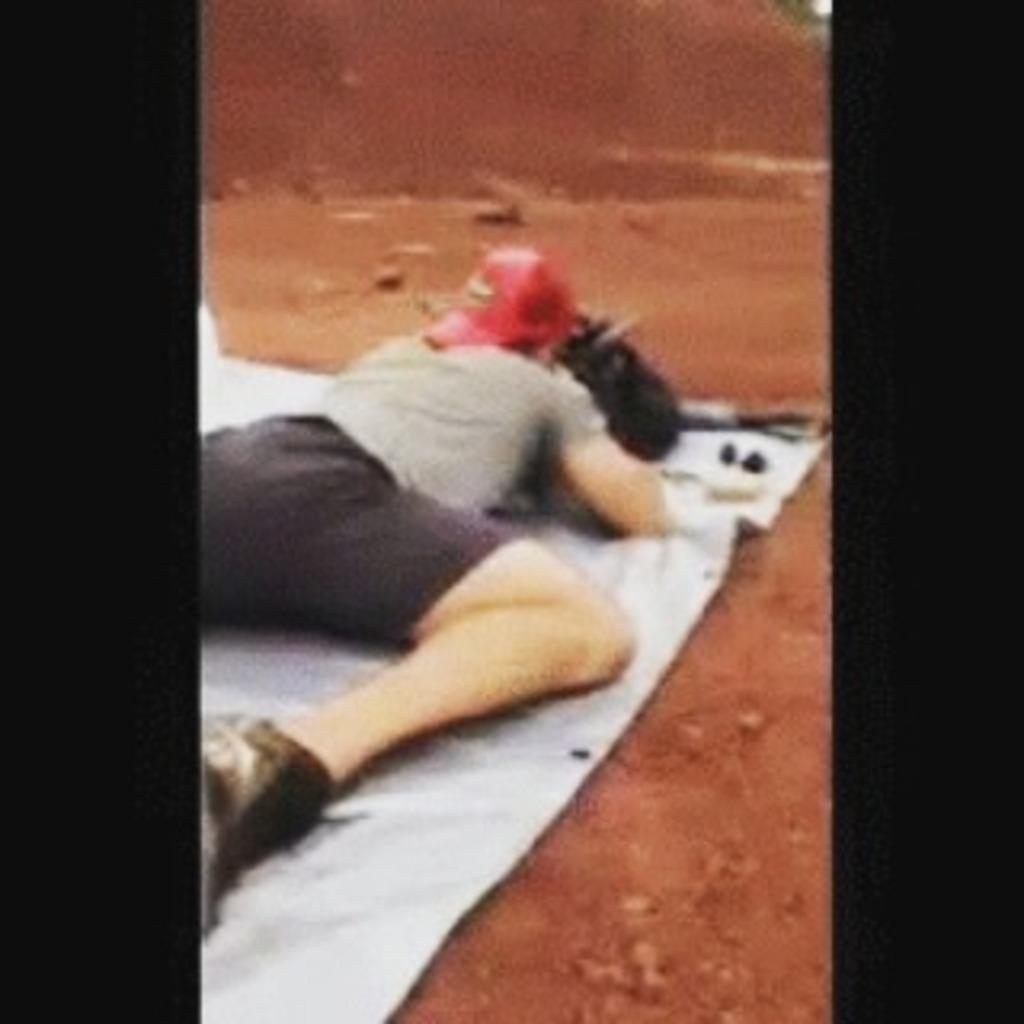What is the man doing in the image? The man is lying on a white cloth in the image. What is the man wearing on his head? The man is wearing a red object on his head. What else can be seen on the ground in the image? There are other objects visible on the ground in the image. How many babies are crawling around the man in the image? There are no babies present in the image; it only features a man lying on a white cloth with a red object on his head and other objects on the ground. 